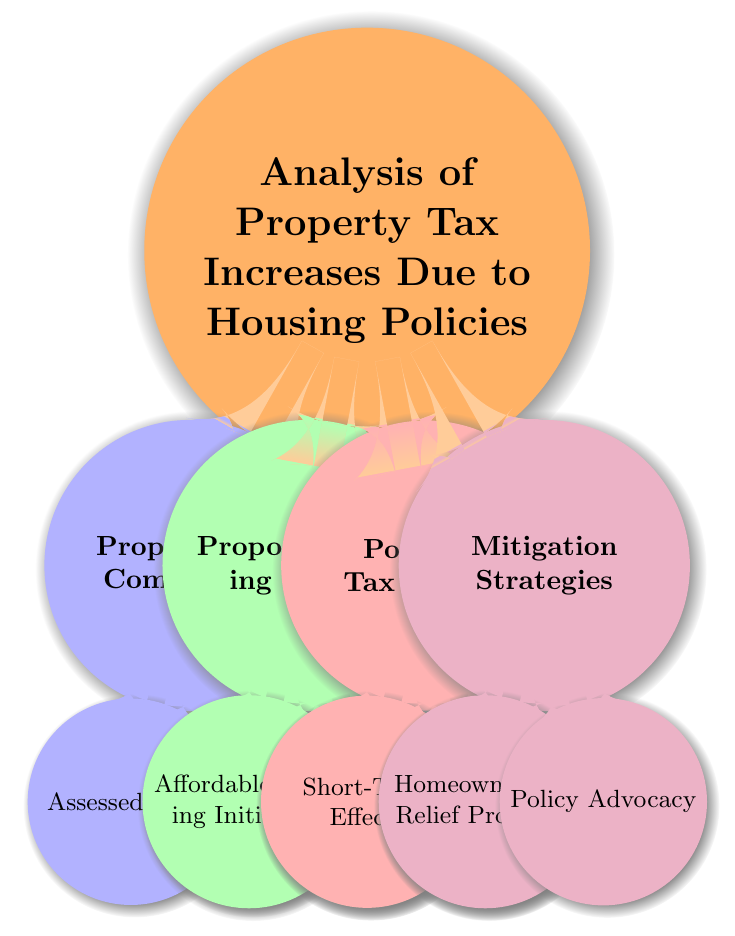What are the main components of property tax? The diagram shows two main categories under “Property Tax Components”: Assessed Value and Tax Rate.
Answer: Assessed Value and Tax Rate How many proposed housing policies are outlined? The diagram lists two proposed housing policies: Affordable Housing Initiatives and Rent Control Measures.
Answer: Two What does “Short-Term Effects” include in potential tax burden? Under Potential Tax Burden, “Short-Term Effects” includes Immediate Tax Hikes and Transition Costs.
Answer: Immediate Tax Hikes and Transition Costs What is one strategy for mitigating the tax burden? The mitigation strategies section has several entries, including Homeowner Tax Relief Programs and Policy Advocacy.
Answer: Homeowner Tax Relief Programs Which proposed housing policy focuses on credits for property owners? “Affordable Housing Initiatives” includes a specific strategy titled Tax Incentives that mentions credits for property owners.
Answer: Tax Incentives How do “Immediate Tax Hikes” relate to “Sustainable Development”? “Immediate Tax Hikes” fall under Short-Term Effects, while “Sustainable Development” falls under Long-Term Effects, illustrating the contrast between short-term impacts and long-term benefits.
Answer: Contrast What combinations of property tax components may increase overall tax burden? The relationship between an increased Assessed Value due to Market Conditions and an increased Tax Rate due to Local Government Policies may lead to an overall increase in the tax burden.
Answer: Increased Assessed Value and Increased Tax Rate What types of expenses are included in regulatory compliance costs? Regulatory compliance costs refer to expenses incurred by landlords in adhering to new Rent Control Measures, which relates to the potential tax burden section.
Answer: Expenses for meeting new regulations How many levels are in the hierarchy of the mind map? The diagram has a root level, and every other category can be divided into up to two additional levels of hierarchy, leading to a total of three levels visible in the map.
Answer: Three 